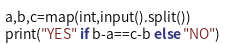Convert code to text. <code><loc_0><loc_0><loc_500><loc_500><_Python_>a,b,c=map(int,input().split())
print("YES" if b-a==c-b else "NO")
</code> 